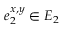Convert formula to latex. <formula><loc_0><loc_0><loc_500><loc_500>e _ { 2 } ^ { x , y } \in E _ { 2 }</formula> 